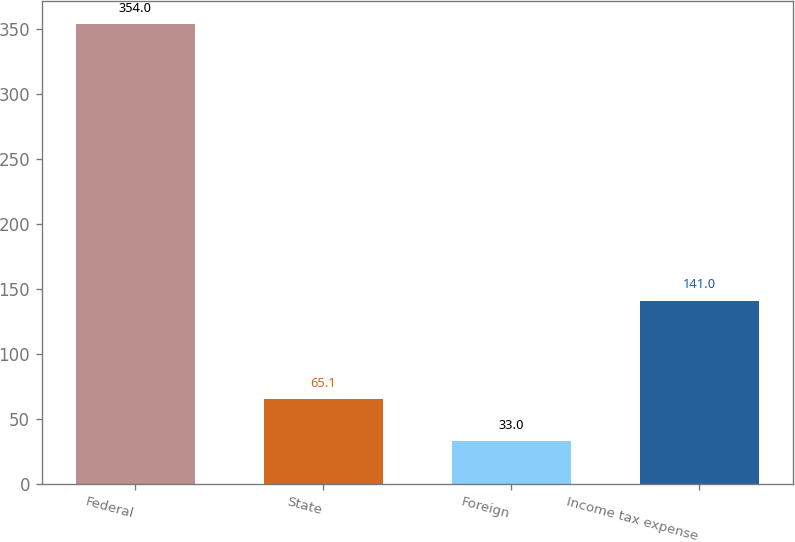Convert chart. <chart><loc_0><loc_0><loc_500><loc_500><bar_chart><fcel>Federal<fcel>State<fcel>Foreign<fcel>Income tax expense<nl><fcel>354<fcel>65.1<fcel>33<fcel>141<nl></chart> 